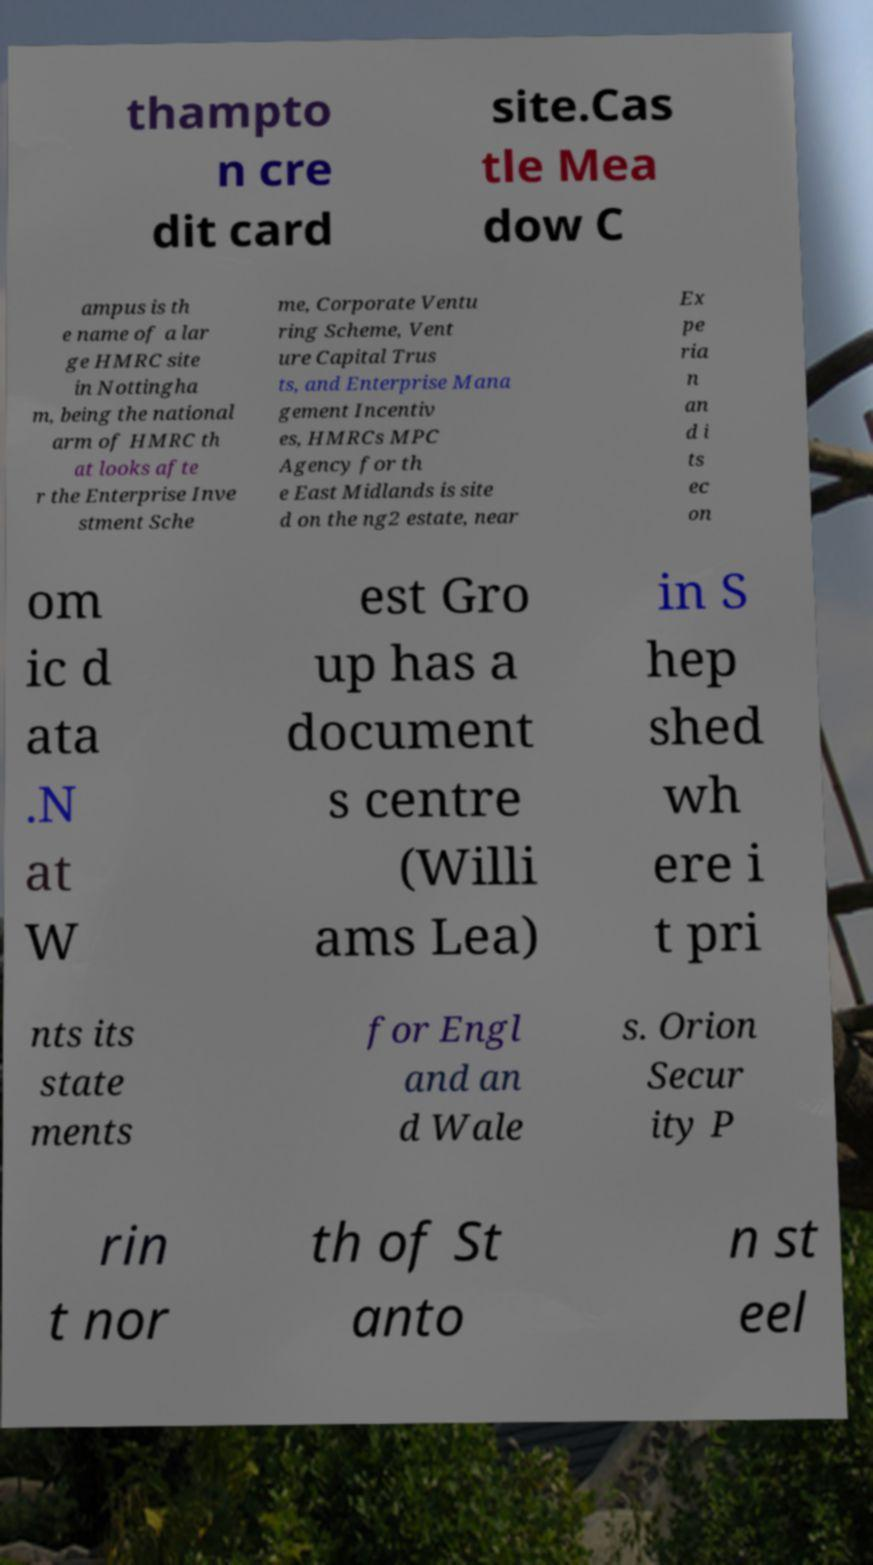There's text embedded in this image that I need extracted. Can you transcribe it verbatim? thampto n cre dit card site.Cas tle Mea dow C ampus is th e name of a lar ge HMRC site in Nottingha m, being the national arm of HMRC th at looks afte r the Enterprise Inve stment Sche me, Corporate Ventu ring Scheme, Vent ure Capital Trus ts, and Enterprise Mana gement Incentiv es, HMRCs MPC Agency for th e East Midlands is site d on the ng2 estate, near Ex pe ria n an d i ts ec on om ic d ata .N at W est Gro up has a document s centre (Willi ams Lea) in S hep shed wh ere i t pri nts its state ments for Engl and an d Wale s. Orion Secur ity P rin t nor th of St anto n st eel 